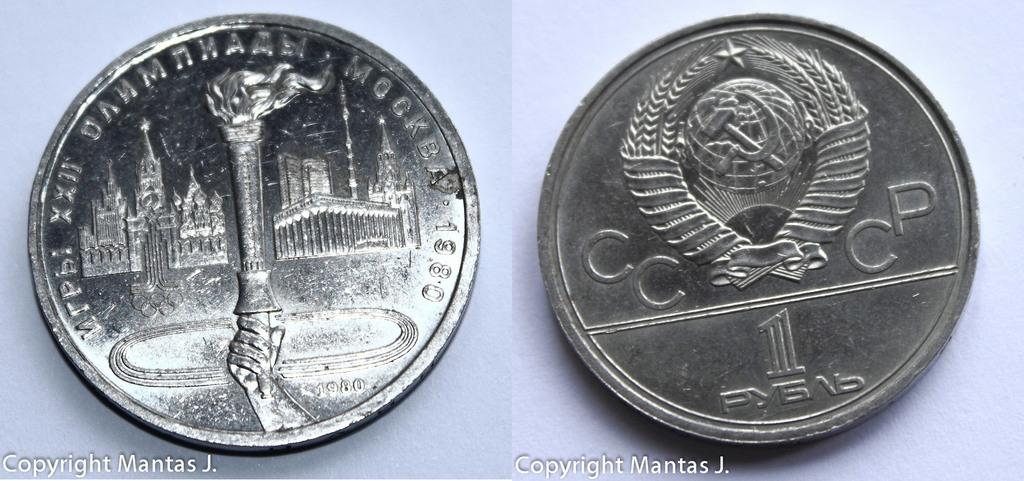<image>
Present a compact description of the photo's key features. A coin is featured in a photo that is copyrighted by Mantas J. 